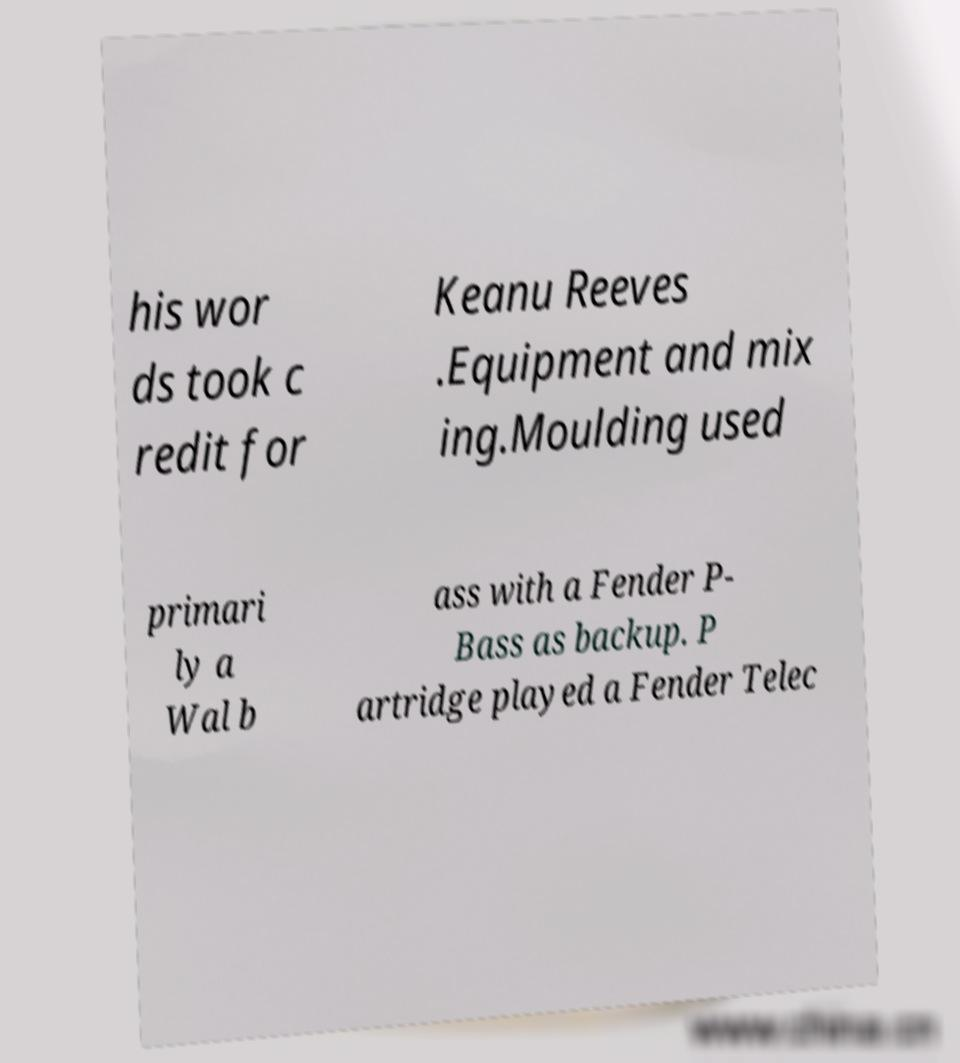Could you extract and type out the text from this image? his wor ds took c redit for Keanu Reeves .Equipment and mix ing.Moulding used primari ly a Wal b ass with a Fender P- Bass as backup. P artridge played a Fender Telec 